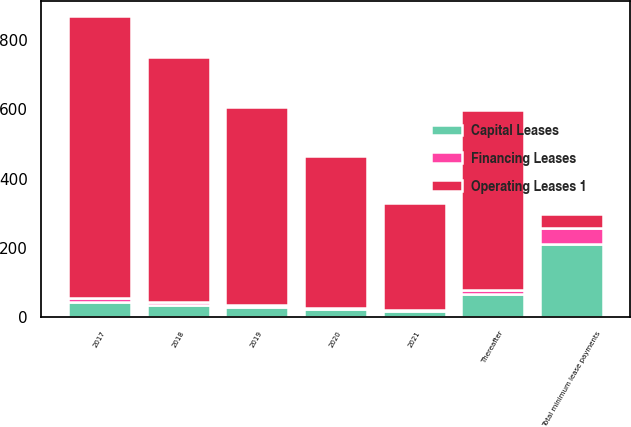Convert chart to OTSL. <chart><loc_0><loc_0><loc_500><loc_500><stacked_bar_chart><ecel><fcel>2017<fcel>2018<fcel>2019<fcel>2020<fcel>2021<fcel>Thereafter<fcel>Total minimum lease payments<nl><fcel>Financing Leases<fcel>14<fcel>9<fcel>6<fcel>3<fcel>2<fcel>12<fcel>46<nl><fcel>Capital Leases<fcel>42<fcel>35<fcel>29<fcel>23<fcel>17<fcel>66<fcel>212<nl><fcel>Operating Leases 1<fcel>813<fcel>708<fcel>572<fcel>439<fcel>310<fcel>521<fcel>38.5<nl></chart> 